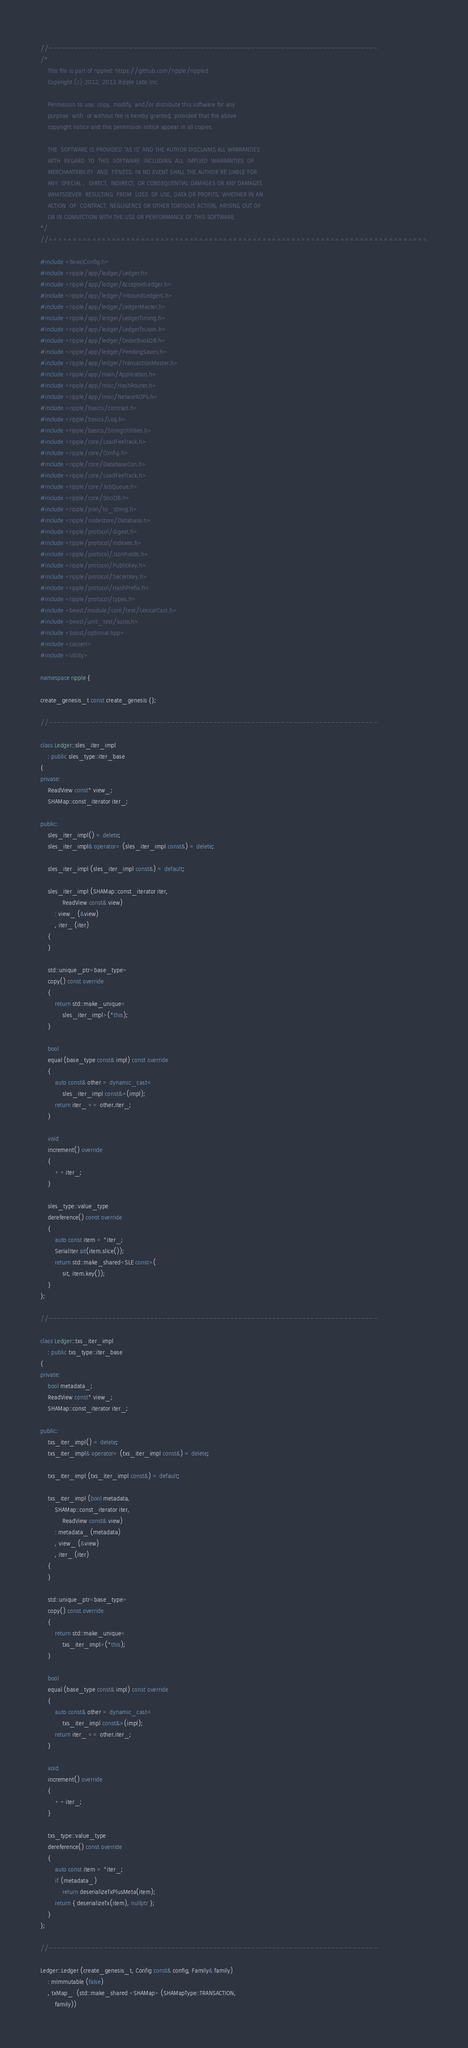<code> <loc_0><loc_0><loc_500><loc_500><_C++_>//------------------------------------------------------------------------------
/*
    This file is part of rippled: https://github.com/ripple/rippled
    Copyright (c) 2012, 2013 Ripple Labs Inc.

    Permission to use, copy, modify, and/or distribute this software for any
    purpose  with  or without fee is hereby granted, provided that the above
    copyright notice and this permission notice appear in all copies.

    THE  SOFTWARE IS PROVIDED "AS IS" AND THE AUTHOR DISCLAIMS ALL WARRANTIES
    WITH  REGARD  TO  THIS  SOFTWARE  INCLUDING  ALL  IMPLIED  WARRANTIES  OF
    MERCHANTABILITY  AND  FITNESS. IN NO EVENT SHALL THE AUTHOR BE LIABLE FOR
    ANY  SPECIAL ,  DIRECT, INDIRECT, OR CONSEQUENTIAL DAMAGES OR ANY DAMAGES
    WHATSOEVER  RESULTING  FROM  LOSS  OF USE, DATA OR PROFITS, WHETHER IN AN
    ACTION  OF  CONTRACT, NEGLIGENCE OR OTHER TORTIOUS ACTION, ARISING OUT OF
    OR IN CONNECTION WITH THE USE OR PERFORMANCE OF THIS SOFTWARE.
*/
//==============================================================================

#include <BeastConfig.h>
#include <ripple/app/ledger/Ledger.h>
#include <ripple/app/ledger/AcceptedLedger.h>
#include <ripple/app/ledger/InboundLedgers.h>
#include <ripple/app/ledger/LedgerMaster.h>
#include <ripple/app/ledger/LedgerTiming.h>
#include <ripple/app/ledger/LedgerToJson.h>
#include <ripple/app/ledger/OrderBookDB.h>
#include <ripple/app/ledger/PendingSaves.h>
#include <ripple/app/ledger/TransactionMaster.h>
#include <ripple/app/main/Application.h>
#include <ripple/app/misc/HashRouter.h>
#include <ripple/app/misc/NetworkOPs.h>
#include <ripple/basics/contract.h>
#include <ripple/basics/Log.h>
#include <ripple/basics/StringUtilities.h>
#include <ripple/core/LoadFeeTrack.h>
#include <ripple/core/Config.h>
#include <ripple/core/DatabaseCon.h>
#include <ripple/core/LoadFeeTrack.h>
#include <ripple/core/JobQueue.h>
#include <ripple/core/SociDB.h>
#include <ripple/json/to_string.h>
#include <ripple/nodestore/Database.h>
#include <ripple/protocol/digest.h>
#include <ripple/protocol/Indexes.h>
#include <ripple/protocol/JsonFields.h>
#include <ripple/protocol/PublicKey.h>
#include <ripple/protocol/SecretKey.h>
#include <ripple/protocol/HashPrefix.h>
#include <ripple/protocol/types.h>
#include <beast/module/core/text/LexicalCast.h>
#include <beast/unit_test/suite.h>
#include <boost/optional.hpp>
#include <cassert>
#include <utility>

namespace ripple {

create_genesis_t const create_genesis {};

//------------------------------------------------------------------------------

class Ledger::sles_iter_impl
    : public sles_type::iter_base
{
private:
    ReadView const* view_;
    SHAMap::const_iterator iter_;

public:
    sles_iter_impl() = delete;
    sles_iter_impl& operator= (sles_iter_impl const&) = delete;

    sles_iter_impl (sles_iter_impl const&) = default;

    sles_iter_impl (SHAMap::const_iterator iter,
            ReadView const& view)
        : view_ (&view)
        , iter_ (iter)
    {
    }

    std::unique_ptr<base_type>
    copy() const override
    {
        return std::make_unique<
            sles_iter_impl>(*this);
    }

    bool
    equal (base_type const& impl) const override
    {
        auto const& other = dynamic_cast<
            sles_iter_impl const&>(impl);
        return iter_ == other.iter_;
    }

    void
    increment() override
    {
        ++iter_;
    }

    sles_type::value_type
    dereference() const override
    {
        auto const item = *iter_;
        SerialIter sit(item.slice());
        return std::make_shared<SLE const>(
            sit, item.key());
    }
};

//------------------------------------------------------------------------------

class Ledger::txs_iter_impl
    : public txs_type::iter_base
{
private:
    bool metadata_;
    ReadView const* view_;
    SHAMap::const_iterator iter_;

public:
    txs_iter_impl() = delete;
    txs_iter_impl& operator= (txs_iter_impl const&) = delete;

    txs_iter_impl (txs_iter_impl const&) = default;

    txs_iter_impl (bool metadata,
        SHAMap::const_iterator iter,
            ReadView const& view)
        : metadata_ (metadata)
        , view_ (&view)
        , iter_ (iter)
    {
    }

    std::unique_ptr<base_type>
    copy() const override
    {
        return std::make_unique<
            txs_iter_impl>(*this);
    }

    bool
    equal (base_type const& impl) const override
    {
        auto const& other = dynamic_cast<
            txs_iter_impl const&>(impl);
        return iter_ == other.iter_;
    }

    void
    increment() override
    {
        ++iter_;
    }

    txs_type::value_type
    dereference() const override
    {
        auto const item = *iter_;
        if (metadata_)
            return deserializeTxPlusMeta(item);
        return { deserializeTx(item), nullptr };
    }
};

//------------------------------------------------------------------------------

Ledger::Ledger (create_genesis_t, Config const& config, Family& family)
    : mImmutable (false)
    , txMap_  (std::make_shared <SHAMap> (SHAMapType::TRANSACTION,
        family))</code> 